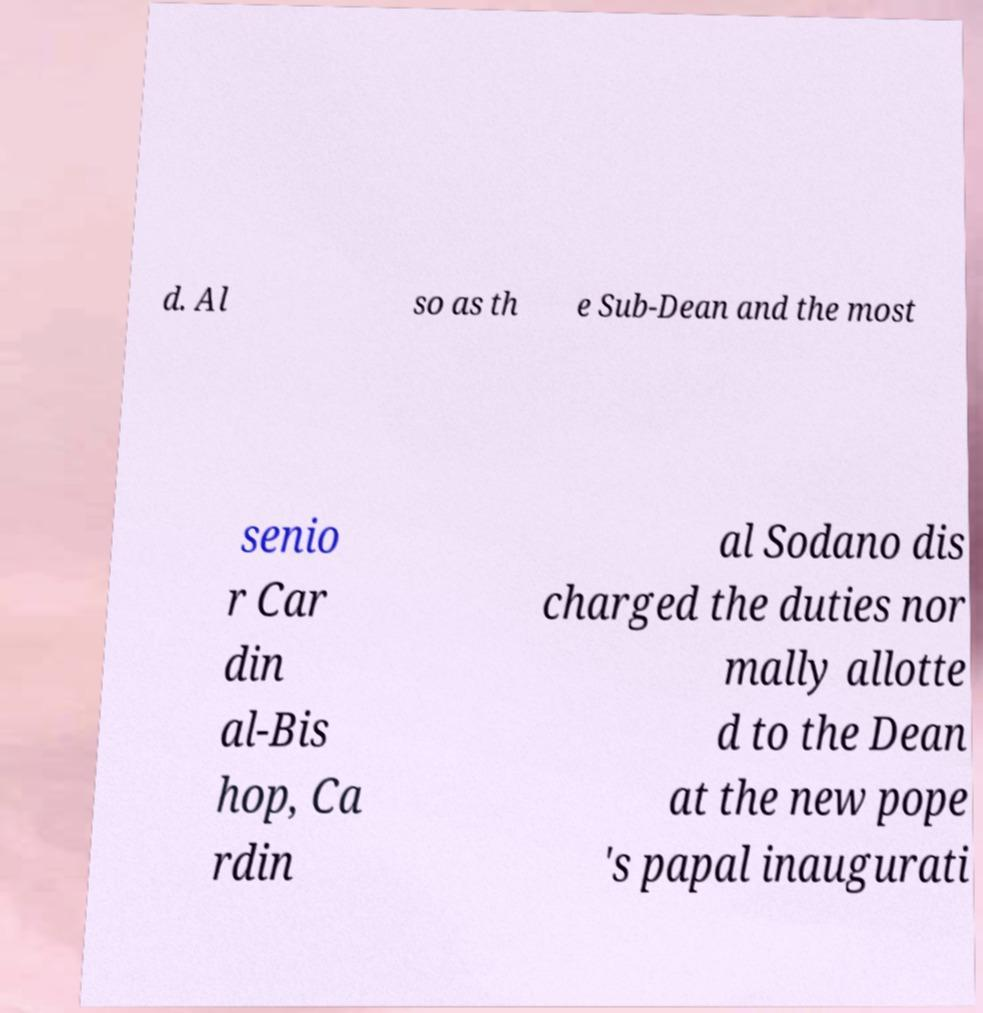What messages or text are displayed in this image? I need them in a readable, typed format. d. Al so as th e Sub-Dean and the most senio r Car din al-Bis hop, Ca rdin al Sodano dis charged the duties nor mally allotte d to the Dean at the new pope 's papal inaugurati 